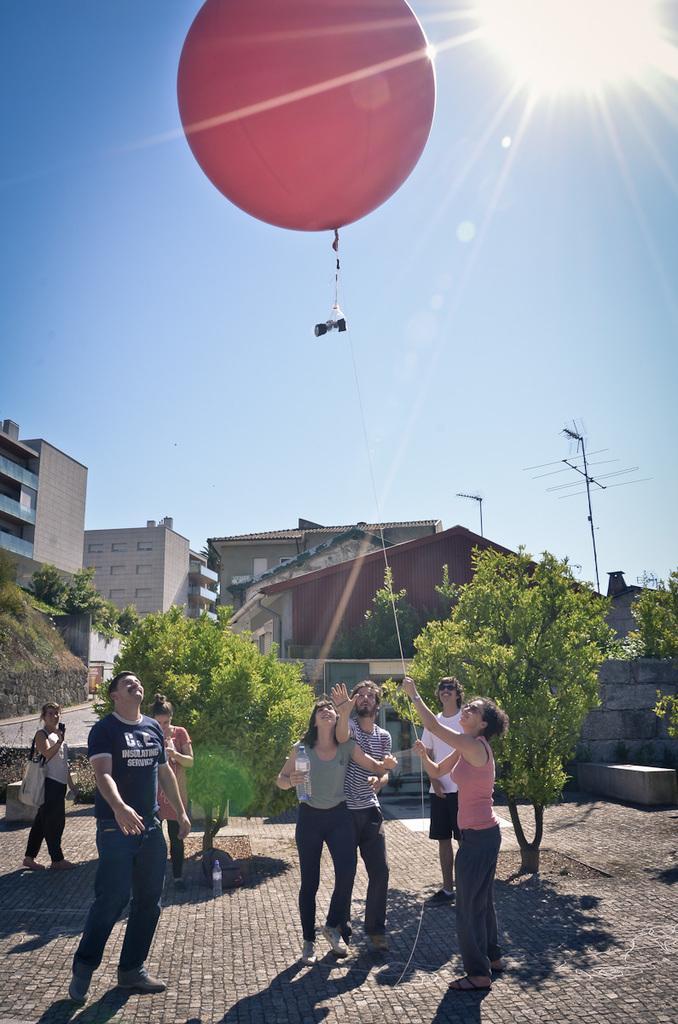Describe this image in one or two sentences. In this picture there are group of people standing and there is a woman with pink t-shirt is standing and holding the balloon. At the back there are buildings and trees and poles. At the top there is sky and there is a sun. 